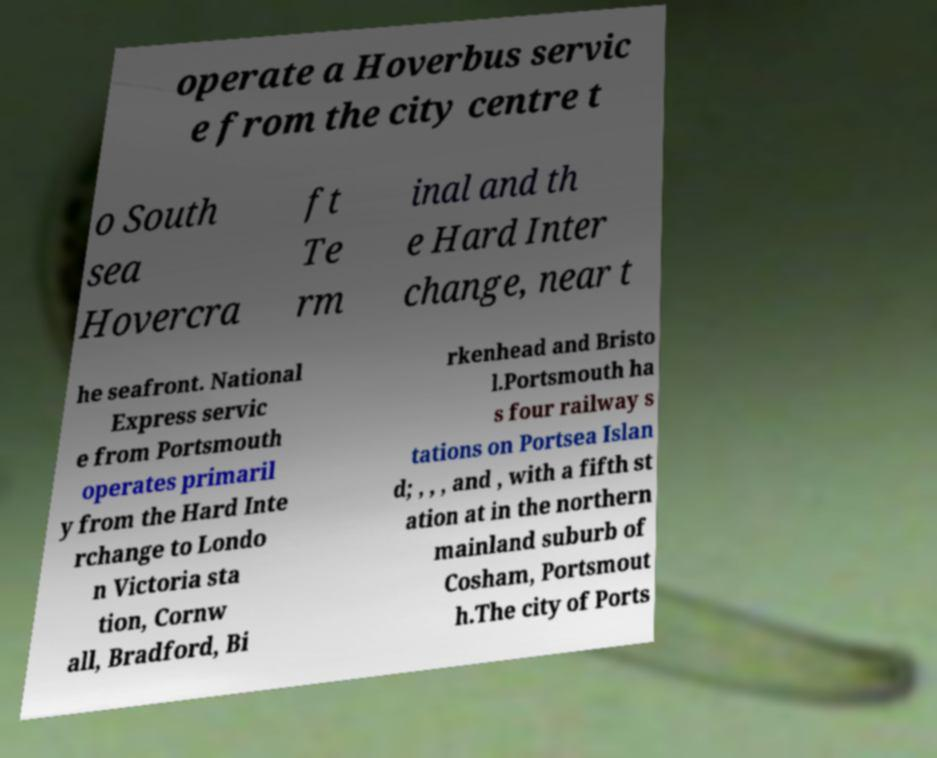What messages or text are displayed in this image? I need them in a readable, typed format. operate a Hoverbus servic e from the city centre t o South sea Hovercra ft Te rm inal and th e Hard Inter change, near t he seafront. National Express servic e from Portsmouth operates primaril y from the Hard Inte rchange to Londo n Victoria sta tion, Cornw all, Bradford, Bi rkenhead and Bristo l.Portsmouth ha s four railway s tations on Portsea Islan d; , , , and , with a fifth st ation at in the northern mainland suburb of Cosham, Portsmout h.The city of Ports 